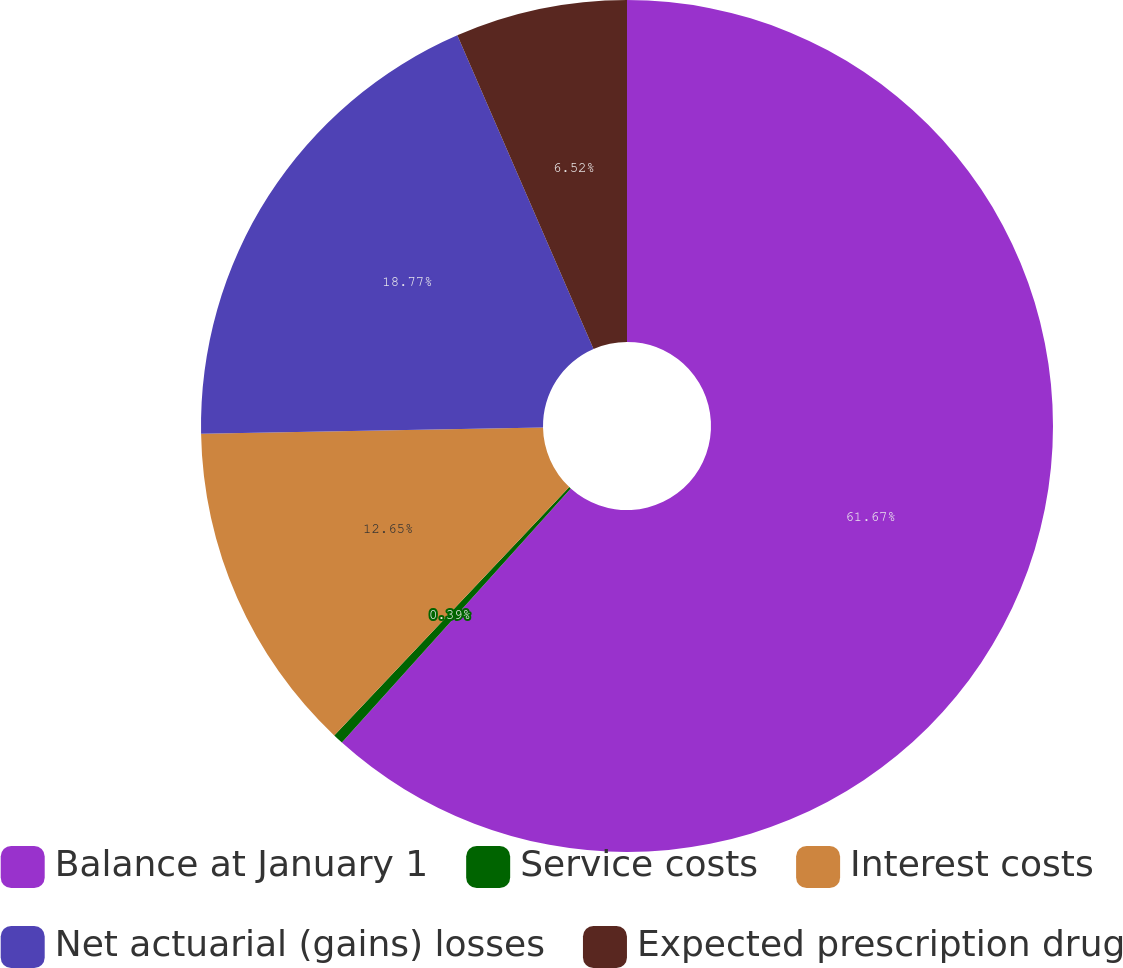Convert chart to OTSL. <chart><loc_0><loc_0><loc_500><loc_500><pie_chart><fcel>Balance at January 1<fcel>Service costs<fcel>Interest costs<fcel>Net actuarial (gains) losses<fcel>Expected prescription drug<nl><fcel>61.67%<fcel>0.39%<fcel>12.65%<fcel>18.77%<fcel>6.52%<nl></chart> 